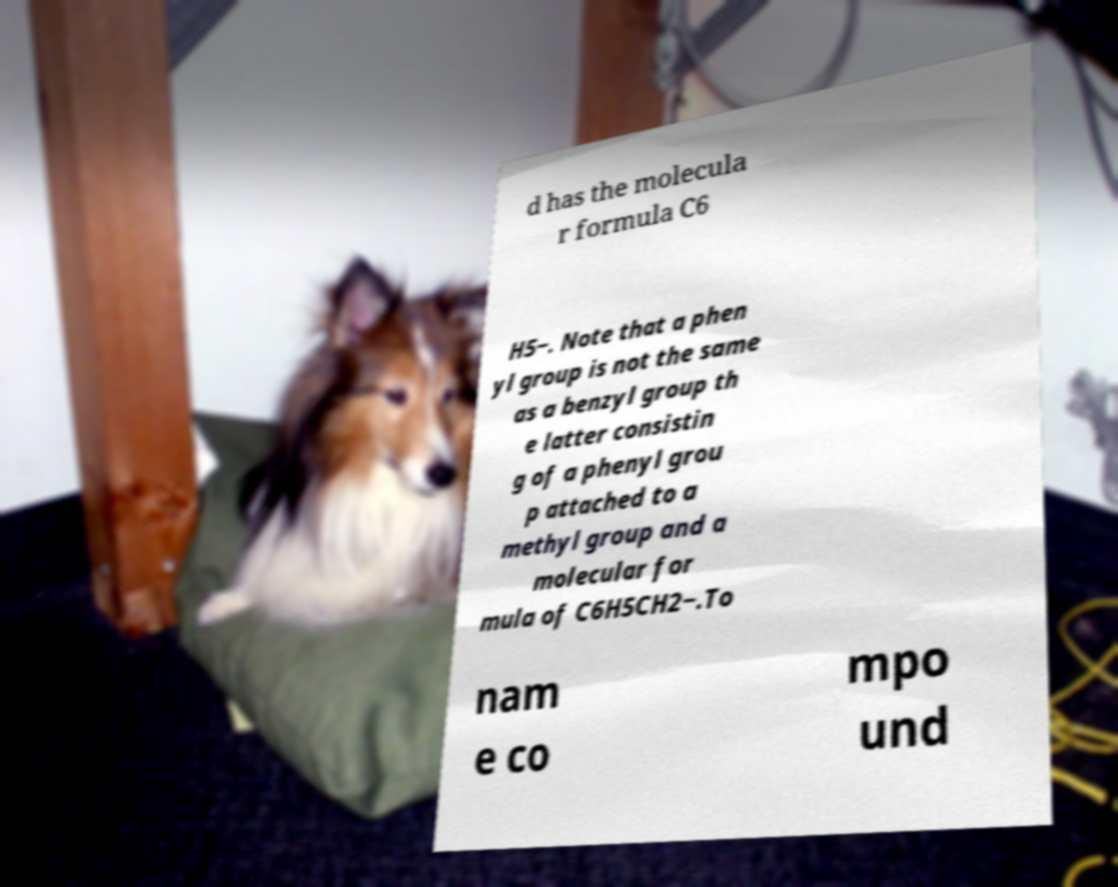Can you read and provide the text displayed in the image?This photo seems to have some interesting text. Can you extract and type it out for me? d has the molecula r formula C6 H5−. Note that a phen yl group is not the same as a benzyl group th e latter consistin g of a phenyl grou p attached to a methyl group and a molecular for mula of C6H5CH2−.To nam e co mpo und 